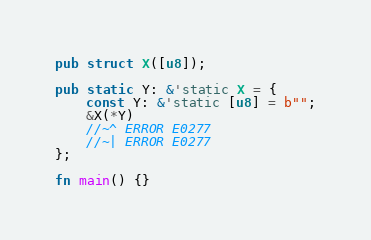Convert code to text. <code><loc_0><loc_0><loc_500><loc_500><_Rust_>pub struct X([u8]);

pub static Y: &'static X = {
    const Y: &'static [u8] = b"";
    &X(*Y)
    //~^ ERROR E0277
    //~| ERROR E0277
};

fn main() {}
</code> 